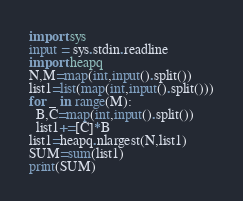<code> <loc_0><loc_0><loc_500><loc_500><_Python_>import sys
input = sys.stdin.readline
import heapq
N,M=map(int,input().split())
list1=list(map(int,input().split()))
for _ in range(M):
  B,C=map(int,input().split())
  list1+=[C]*B
list1=heapq.nlargest(N,list1)
SUM=sum(list1)
print(SUM)</code> 